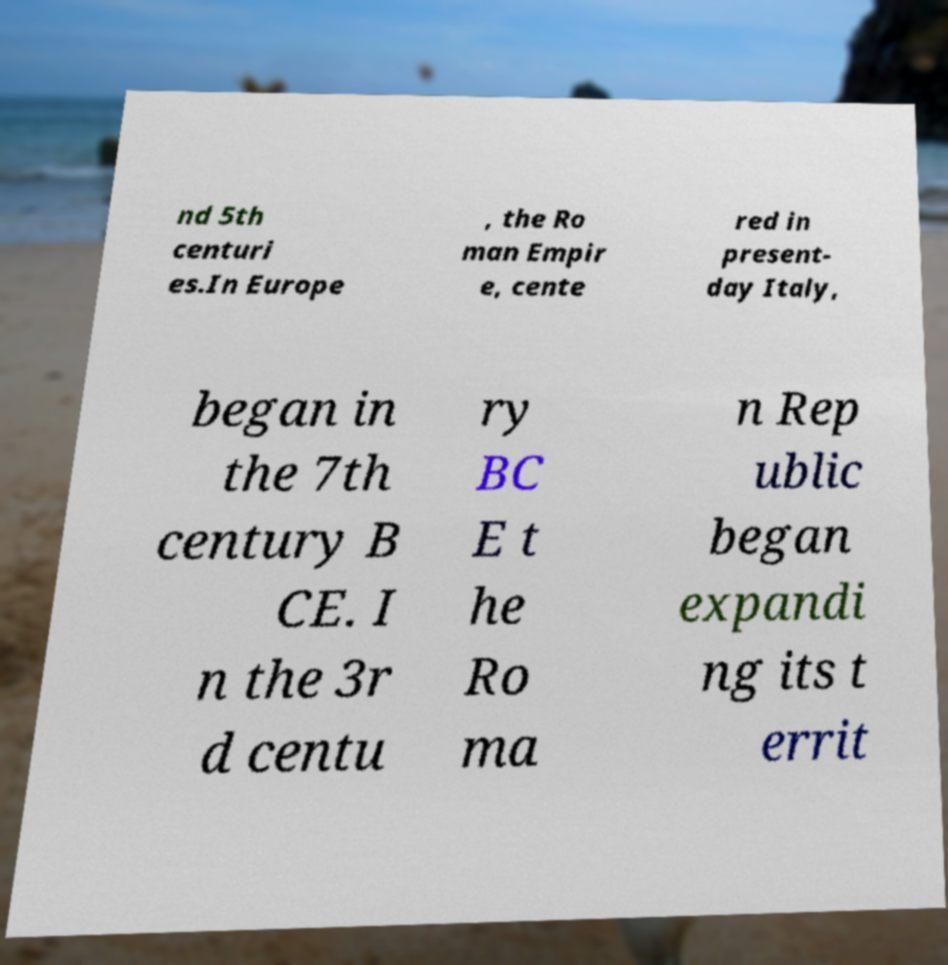Can you accurately transcribe the text from the provided image for me? nd 5th centuri es.In Europe , the Ro man Empir e, cente red in present- day Italy, began in the 7th century B CE. I n the 3r d centu ry BC E t he Ro ma n Rep ublic began expandi ng its t errit 